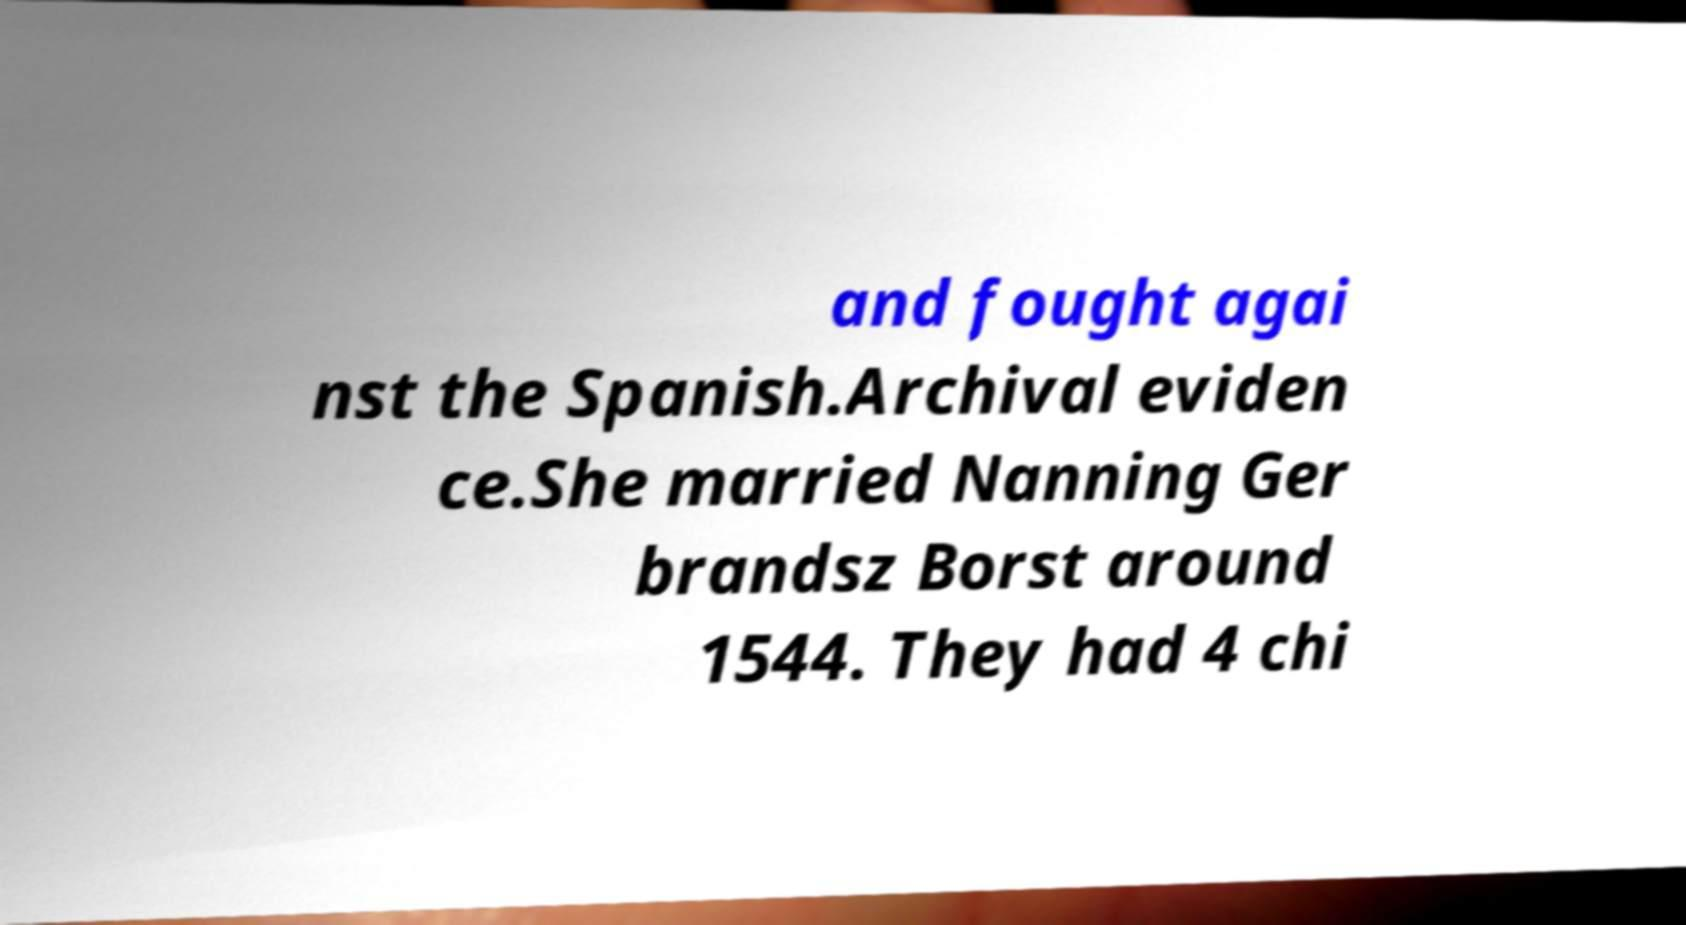For documentation purposes, I need the text within this image transcribed. Could you provide that? and fought agai nst the Spanish.Archival eviden ce.She married Nanning Ger brandsz Borst around 1544. They had 4 chi 